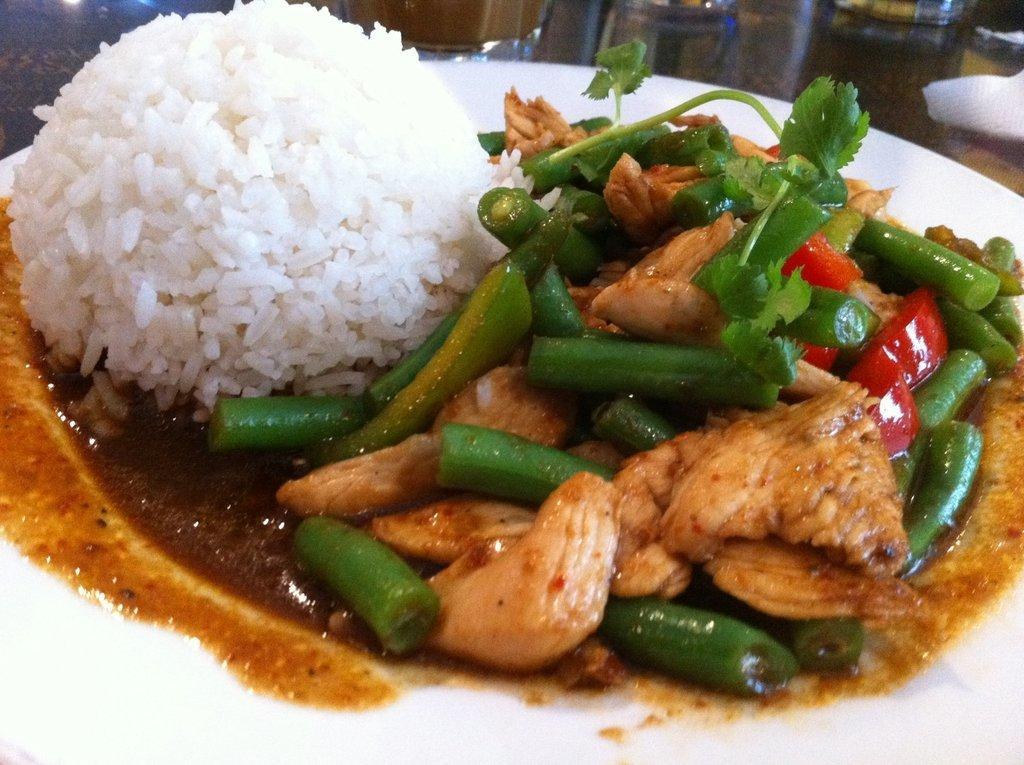Can you describe this image briefly? In this image in the foreground there is one plate, and in the plate there is rice and some food. And in the background there is a tissue paper and some objects. 